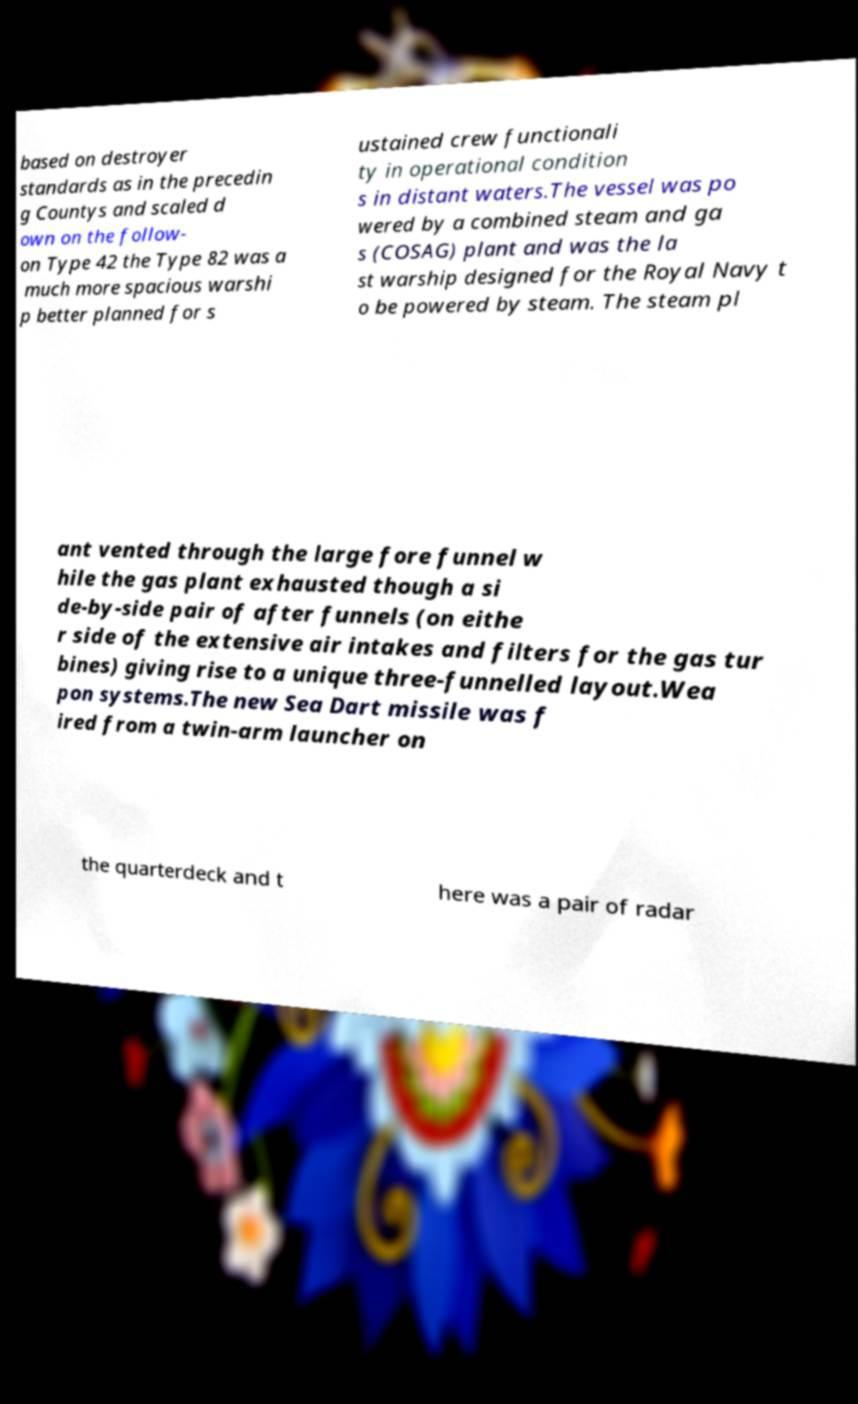There's text embedded in this image that I need extracted. Can you transcribe it verbatim? based on destroyer standards as in the precedin g Countys and scaled d own on the follow- on Type 42 the Type 82 was a much more spacious warshi p better planned for s ustained crew functionali ty in operational condition s in distant waters.The vessel was po wered by a combined steam and ga s (COSAG) plant and was the la st warship designed for the Royal Navy t o be powered by steam. The steam pl ant vented through the large fore funnel w hile the gas plant exhausted though a si de-by-side pair of after funnels (on eithe r side of the extensive air intakes and filters for the gas tur bines) giving rise to a unique three-funnelled layout.Wea pon systems.The new Sea Dart missile was f ired from a twin-arm launcher on the quarterdeck and t here was a pair of radar 